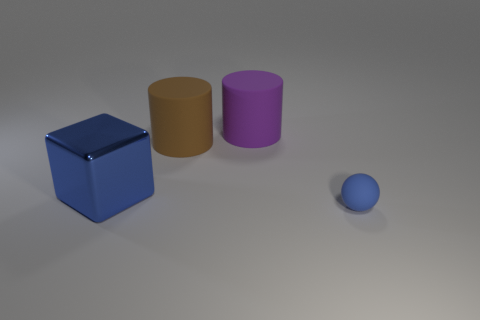Add 2 small brown objects. How many objects exist? 6 Subtract all blocks. How many objects are left? 3 Subtract 0 blue cylinders. How many objects are left? 4 Subtract all big brown objects. Subtract all blue matte things. How many objects are left? 2 Add 4 blue cubes. How many blue cubes are left? 5 Add 4 tiny rubber balls. How many tiny rubber balls exist? 5 